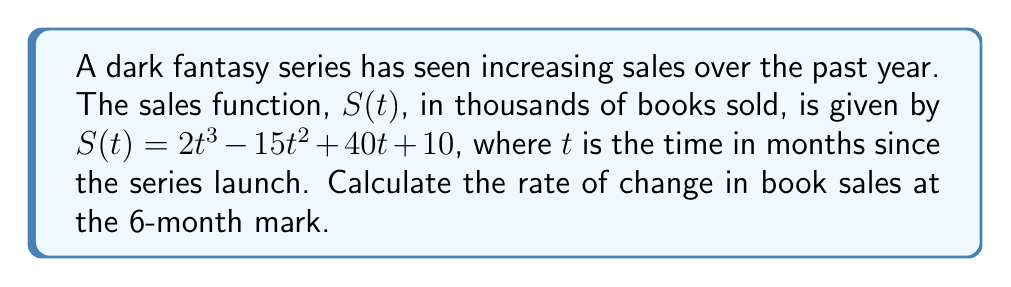Can you answer this question? To find the rate of change in book sales at a specific point in time, we need to calculate the derivative of the sales function $S(t)$ and evaluate it at $t = 6$.

1. First, let's find the derivative of $S(t)$:
   
   $S(t) = 2t^3 - 15t^2 + 40t + 10$
   
   $S'(t) = 6t^2 - 30t + 40$

2. Now, we evaluate $S'(t)$ at $t = 6$:

   $S'(6) = 6(6)^2 - 30(6) + 40$
   
   $= 6(36) - 180 + 40$
   
   $= 216 - 180 + 40$
   
   $= 76$

3. Interpret the result:
   The rate of change at $t = 6$ is 76 thousand books per month.

This means that at the 6-month mark, the sales of the dark fantasy series are increasing at a rate of 76,000 books per month.
Answer: The rate of change in book sales at the 6-month mark is 76,000 books per month. 